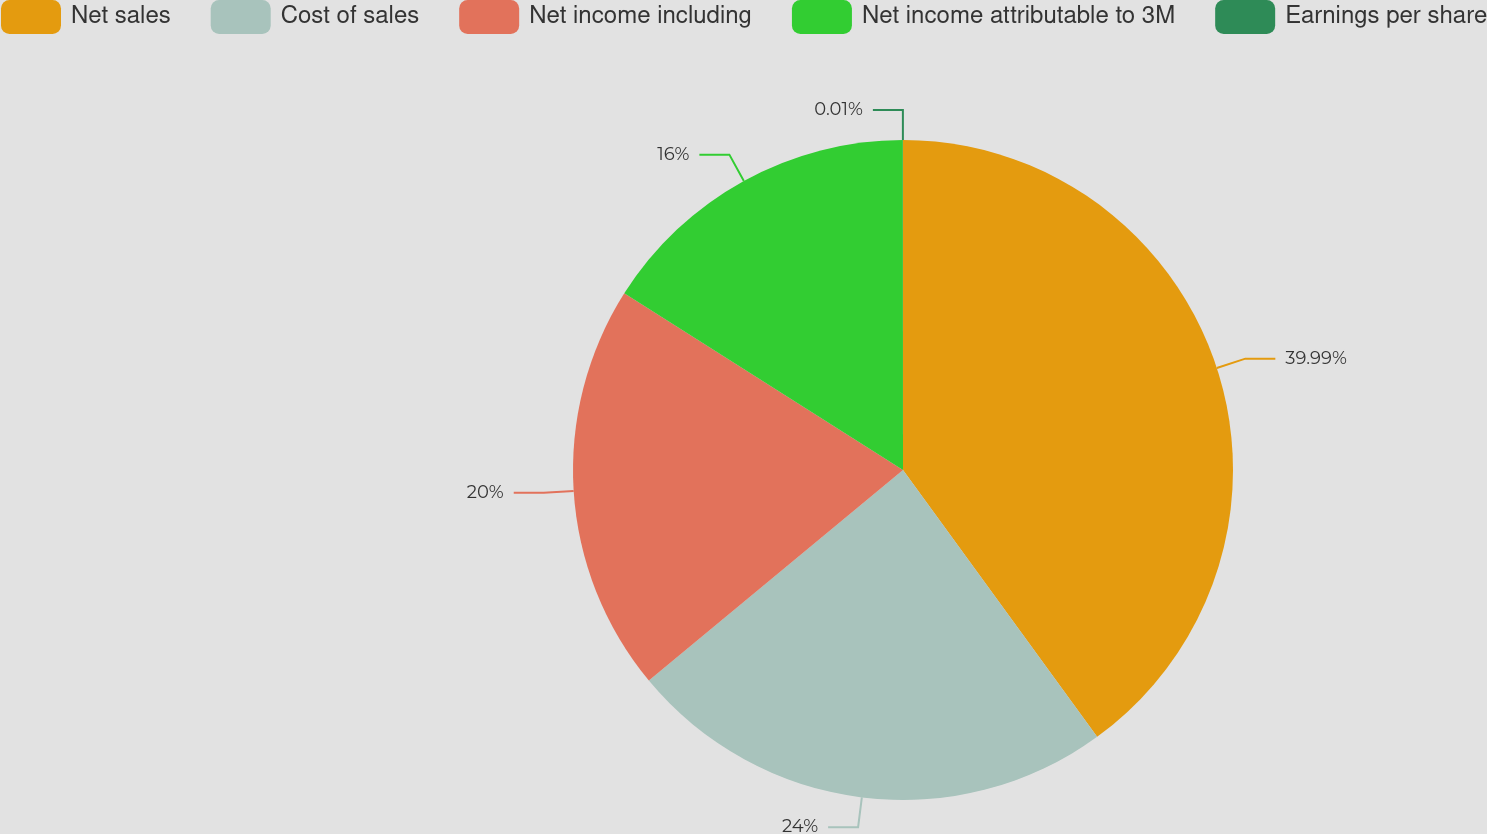Convert chart to OTSL. <chart><loc_0><loc_0><loc_500><loc_500><pie_chart><fcel>Net sales<fcel>Cost of sales<fcel>Net income including<fcel>Net income attributable to 3M<fcel>Earnings per share<nl><fcel>39.99%<fcel>24.0%<fcel>20.0%<fcel>16.0%<fcel>0.01%<nl></chart> 